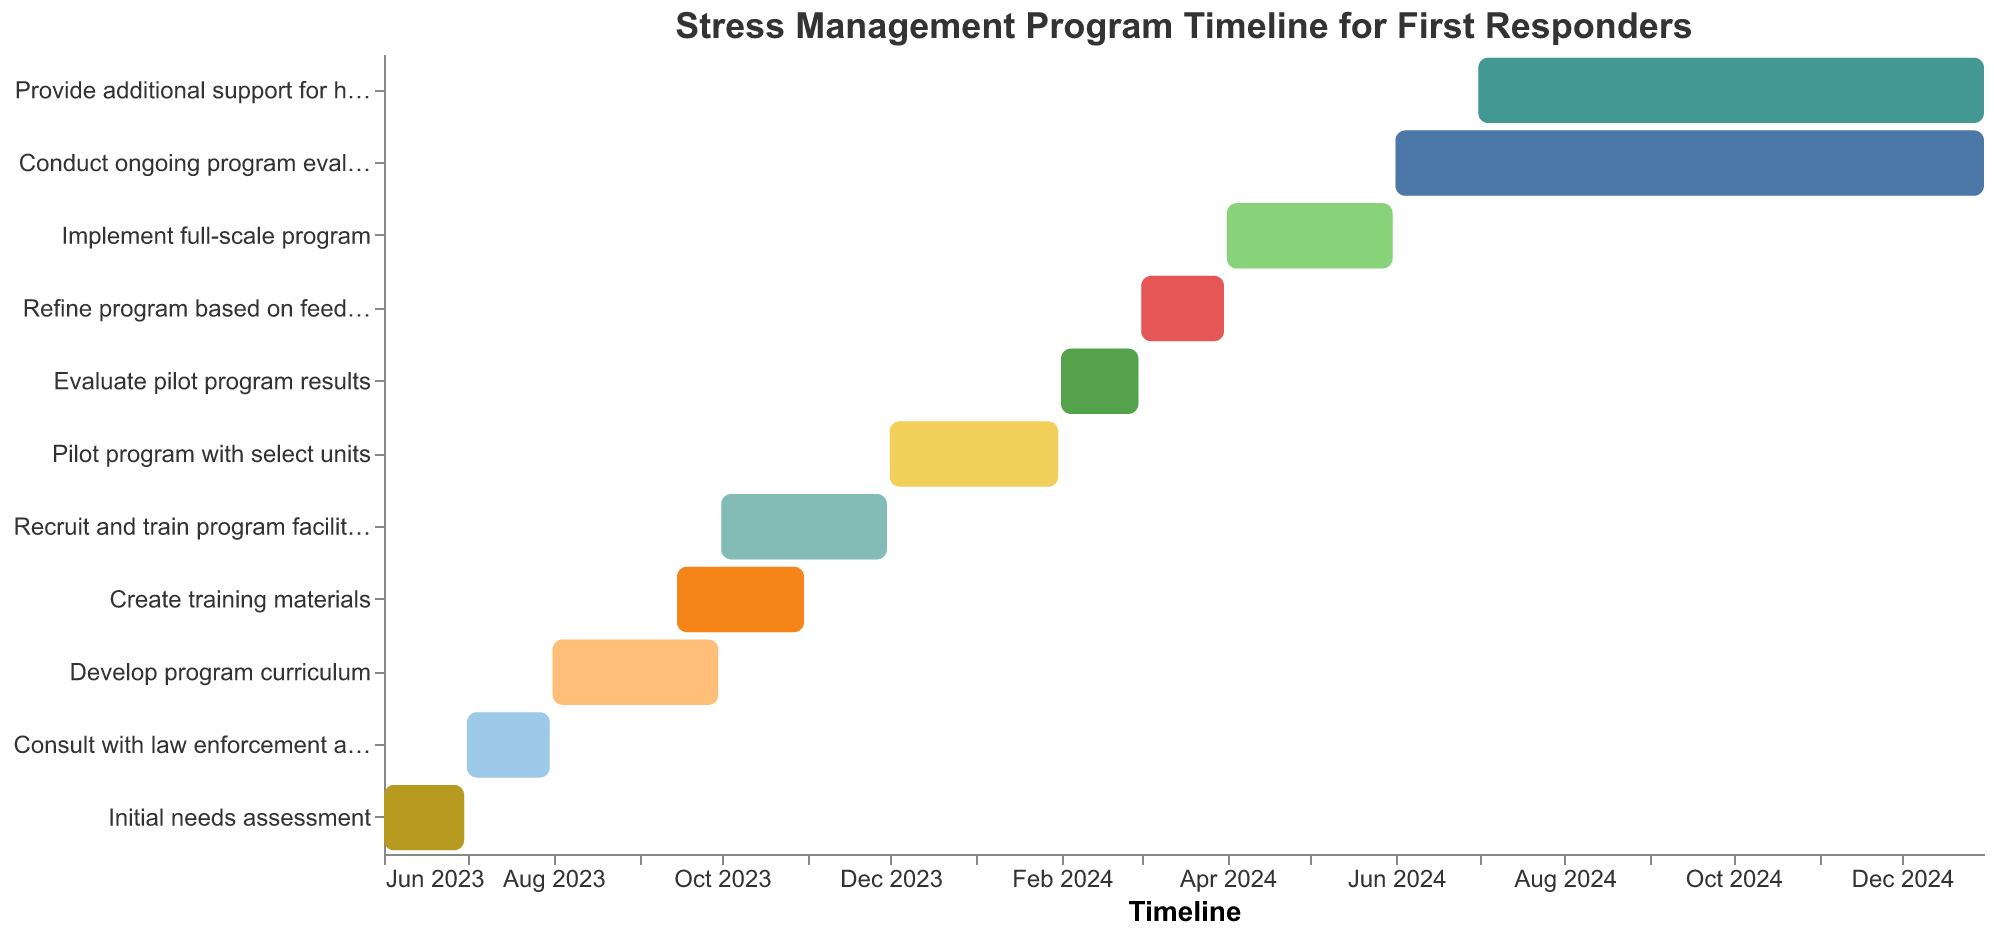What is the total period allocated for developing the program curriculum? First, locate the "Develop program curriculum" task on the y-axis. Then refer to the x-axis for the "Start Date" and "End Date", which are 2023-08-01 and 2023-09-30, respectively. Calculate the period between these dates, which is from August 1 to September 30, totaling 61 days.
Answer: 61 days What task starts immediately after "Consult with law enforcement and first responder agencies"? Locate "Consult with law enforcement and first responder agencies" on the y-axis, which ends on 2023-07-31. The next task on the timeline starting on 2023-08-01 is "Develop program curriculum".
Answer: Develop program curriculum How long will the "Conduct ongoing program evaluation" task take? Locate "Conduct ongoing program evaluation" and check the "Start Date" and "End Date" on the x-axis, which are 2024-06-01 and 2024-12-31, respectively. Calculate the total duration from June 1 to December 31, which spans approximately 7 months or 214 days.
Answer: 214 days Which tasks overlap in the month of October 2023? Identify all tasks on the timeline and check their duration. Both "Create training materials" (2023-09-15 to 2023-10-31) and "Recruit and train program facilitators" (2023-10-01 to 2023-11-30) overlap in October 2023.
Answer: Create training materials and Recruit and train program facilitators What is the final task in the timeline? Check the y-axis for the tasks and scroll to the bottom of the timeline. The final task listed is "Provide additional support for high-stress units", which starts on 2024-07-01 and ends on 2024-12-31.
Answer: Provide additional support for high-stress units How many phases involve direct interaction with first responders? Identify tasks that indicate interaction with first responders on the y-axis, such as "Consult with law enforcement and first responder agencies", "Pilot program with select units", and "Provide additional support for high-stress units". Count these interactions; there are three in total.
Answer: 3 phases Which task has the shortest duration, and how long is it? Compare all tasks on the y-axis for their durations using the "Start Date" and "End Date". The task "Evaluate pilot program results" spans from 2024-02-01 to 2024-02-29, totaling 29 days, the shortest duration.
Answer: Evaluate pilot program results, 29 days Which tasks are being conducted simultaneously in July 2024? On the x-axis, check which tasks overlap in the timeline for July 2024. The tasks "Conduct ongoing program evaluation" (2024-06-01 to 2024-12-31) and "Provide additional support for high-stress units" (2024-07-01 to 2024-12-31) are both active in July 2024.
Answer: Conduct ongoing program evaluation and Provide additional support for high-stress units 